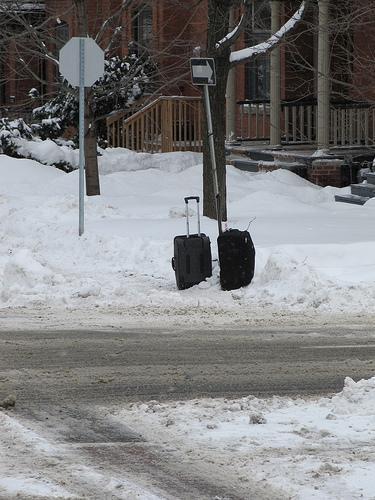How many suitcases are there?
Give a very brief answer. 2. 